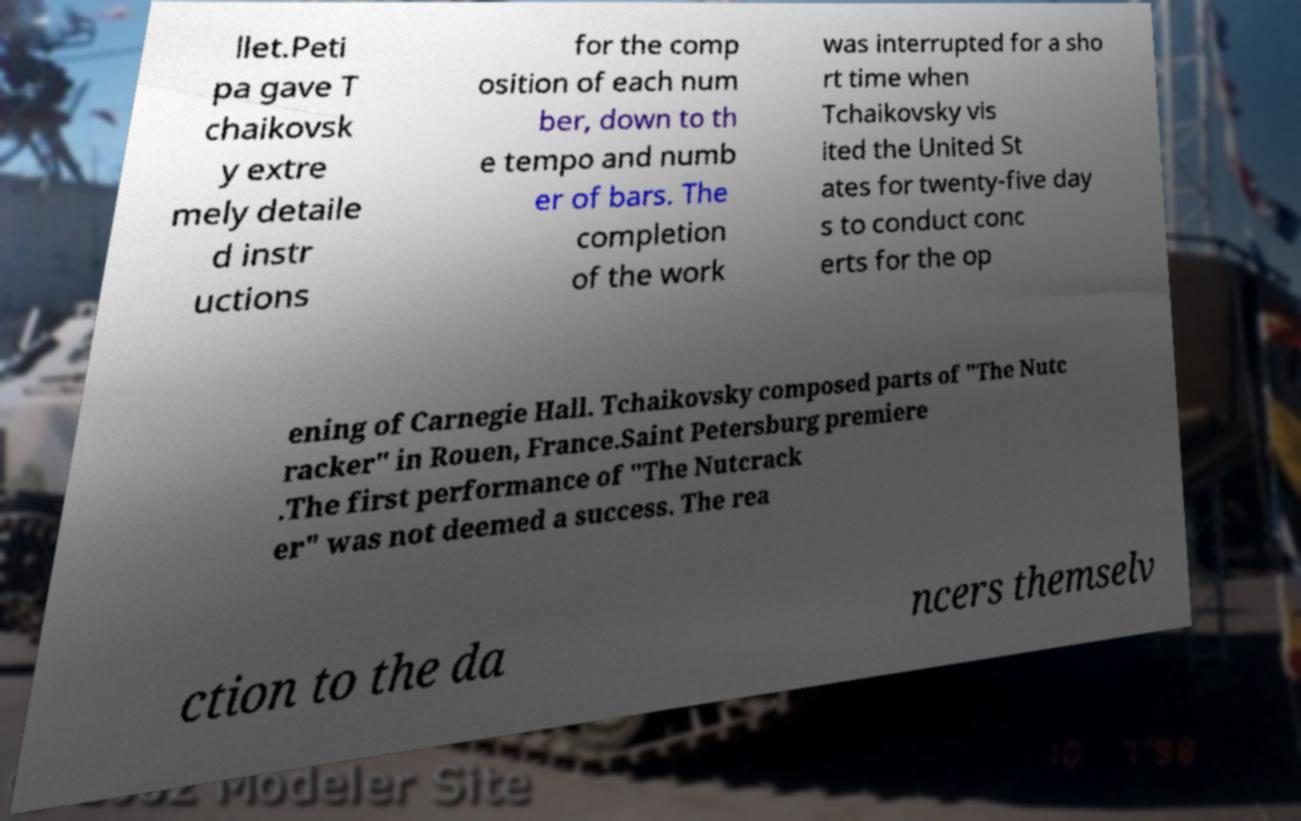There's text embedded in this image that I need extracted. Can you transcribe it verbatim? llet.Peti pa gave T chaikovsk y extre mely detaile d instr uctions for the comp osition of each num ber, down to th e tempo and numb er of bars. The completion of the work was interrupted for a sho rt time when Tchaikovsky vis ited the United St ates for twenty-five day s to conduct conc erts for the op ening of Carnegie Hall. Tchaikovsky composed parts of "The Nutc racker" in Rouen, France.Saint Petersburg premiere .The first performance of "The Nutcrack er" was not deemed a success. The rea ction to the da ncers themselv 